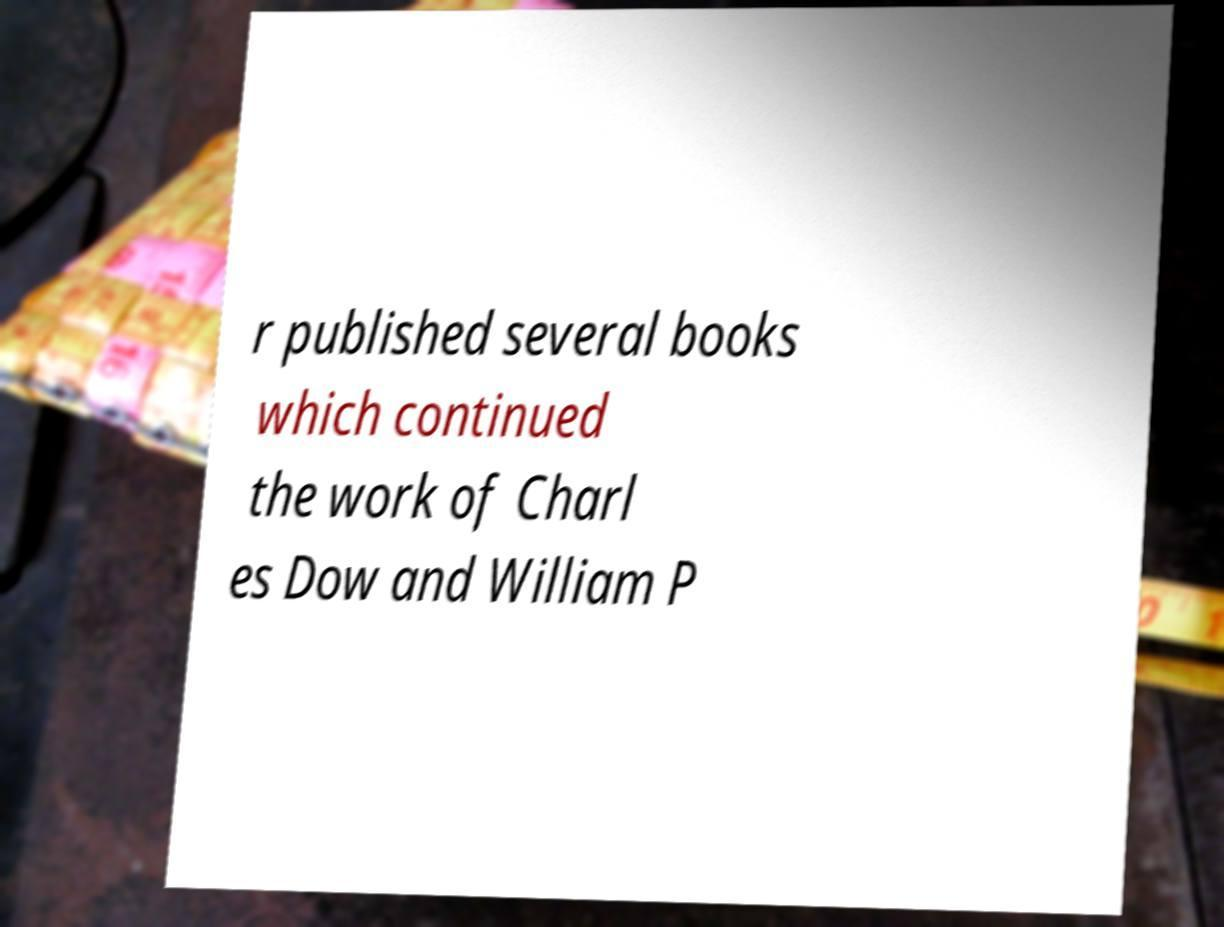Please identify and transcribe the text found in this image. r published several books which continued the work of Charl es Dow and William P 